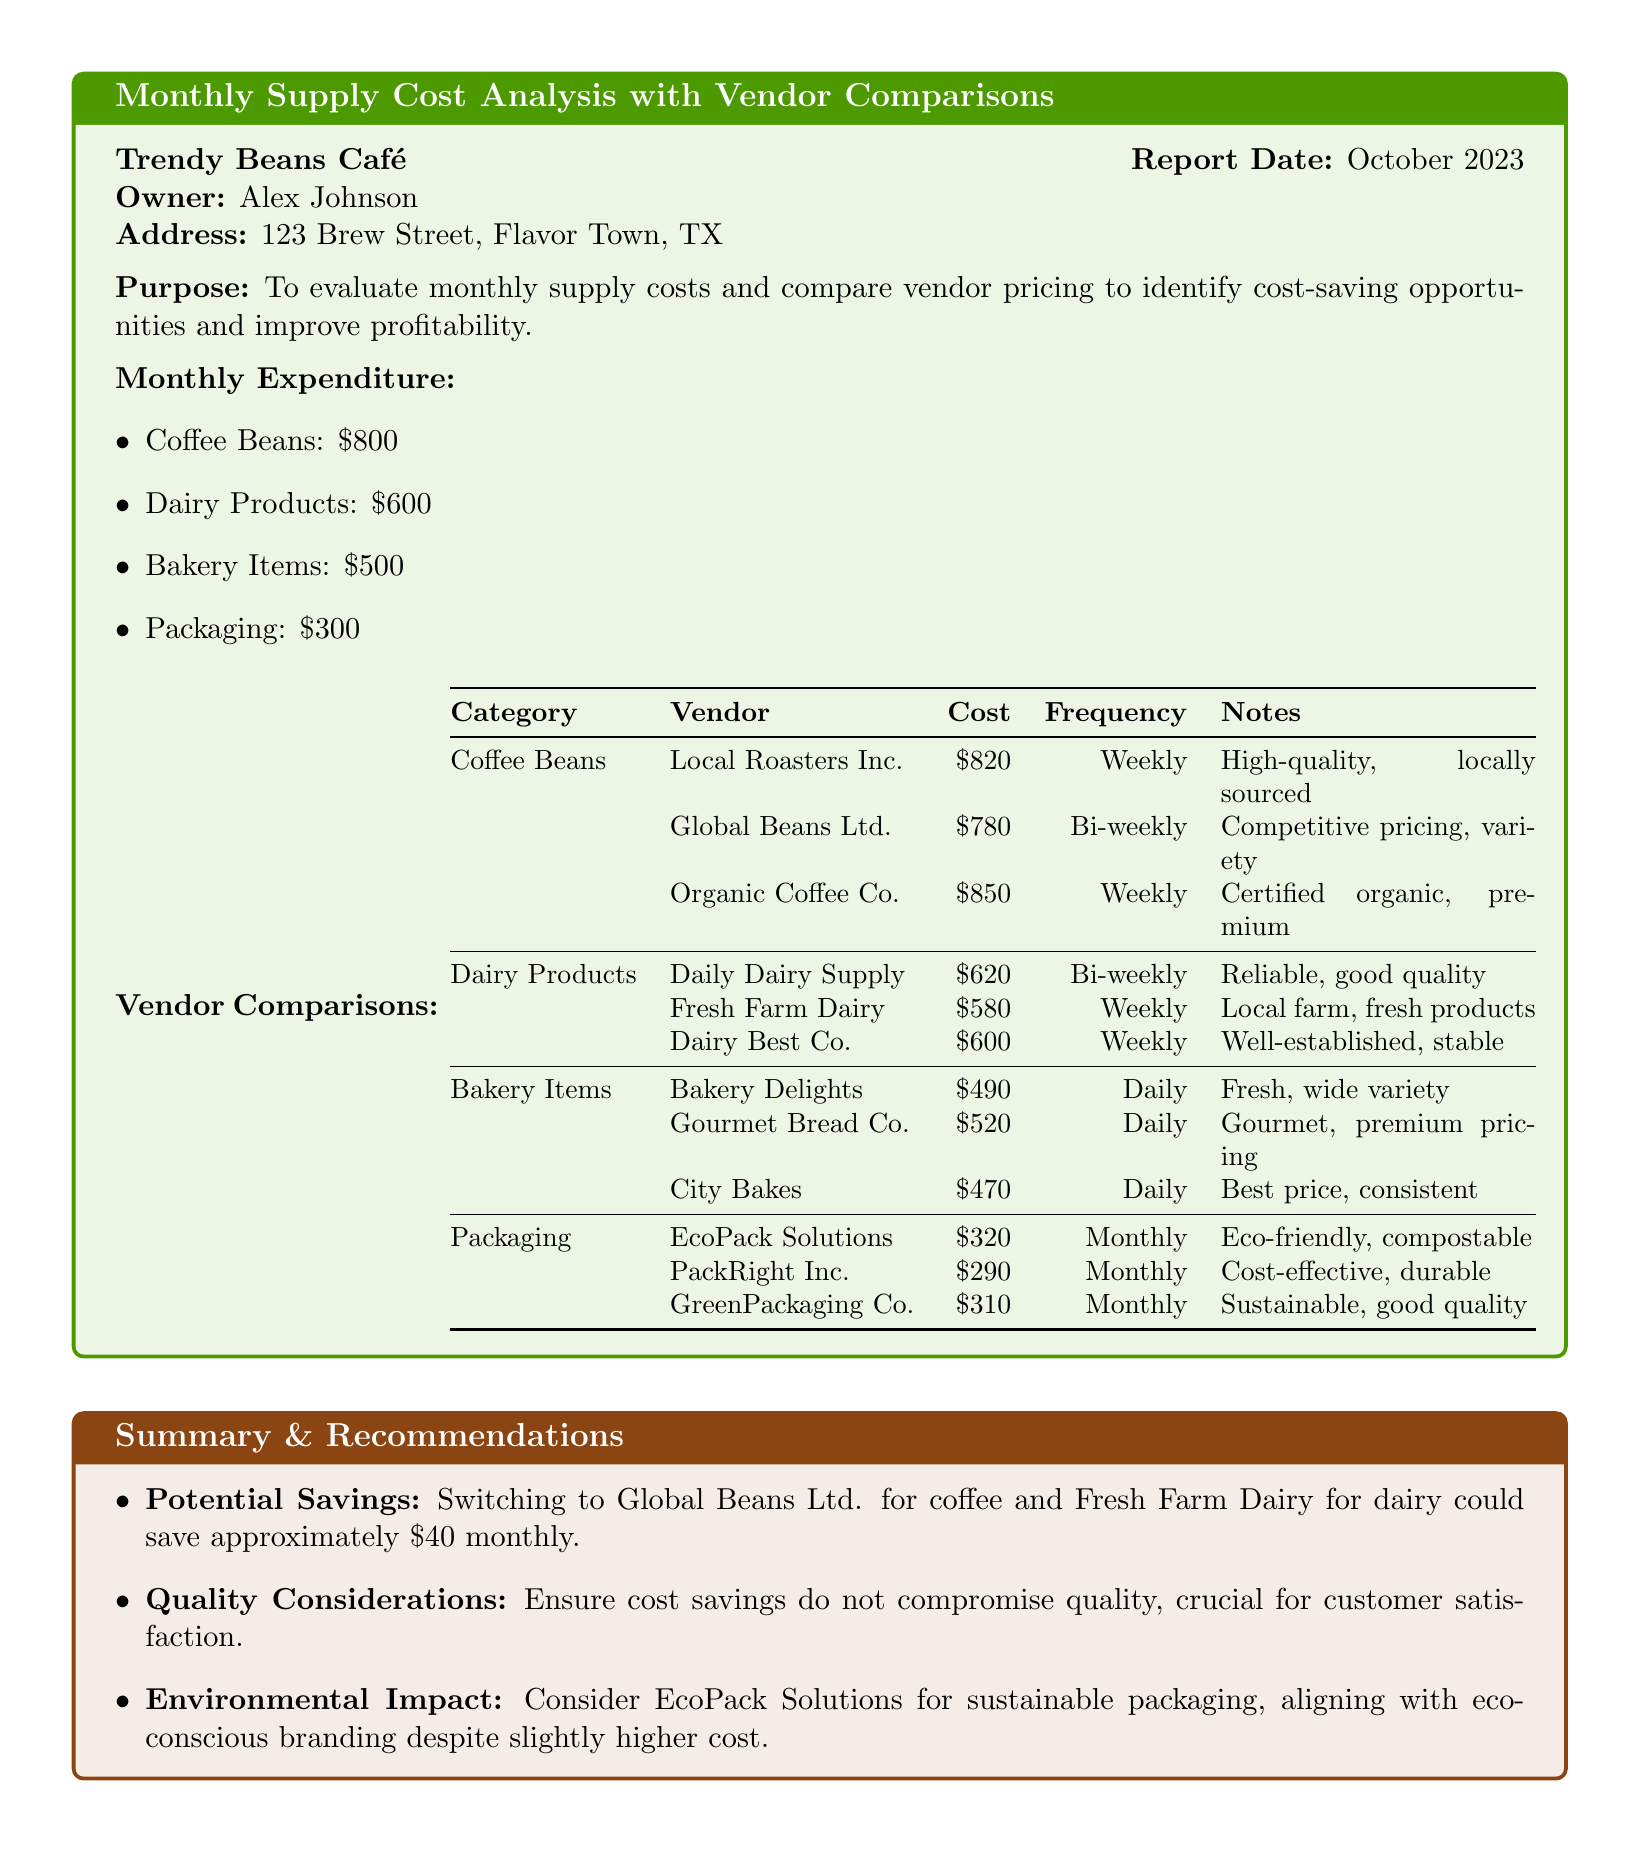What is the report date? The report date is stated in the document to provide a timeframe for the analysis conducted.
Answer: October 2023 Who is the owner of the café? The owner's name is included to identify the individual responsible for the café operations and decisions outlined in the document.
Answer: Alex Johnson How much is spent monthly on dairy products? This figure is directly mentioned in the monthly expenditure section to clarify the café's spending on dairy.
Answer: $600 Which vendor offers the best price for bakery items? The vendor with the lowest cost in the bakery items category is highlighted to assist in making informed purchasing decisions.
Answer: City Bakes What potential savings could be achieved by switching vendors for coffee? This figure indicates the amount that can be saved and emphasizes the cost-saving opportunities available through vendor comparisons.
Answer: $40 Which packaging solution is eco-friendly? This distinction is made to align with sustainable practices important for the café's branding and customer appeal.
Answer: EcoPack Solutions What is the frequency of deliveries from Gourmet Bread Co.? The delivery frequency is noted to understand how often products are supplied, which impacts inventory management.
Answer: Daily What quality consideration is mentioned for vendor selection? This point emphasizes the importance of maintaining quality over solely focusing on costs, which is crucial for maintaining customer satisfaction.
Answer: Ensure cost savings do not compromise quality What is the cost of packaging from PackRight Inc.? The cost is listed to evaluate vendor pricing and compare it with other available options for the same supplies.
Answer: $290 